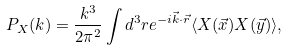<formula> <loc_0><loc_0><loc_500><loc_500>P _ { X } ( k ) = \frac { k ^ { 3 } } { 2 \pi ^ { 2 } } \int d ^ { 3 } r e ^ { - i \vec { k } \cdot \vec { r } } \langle X ( \vec { x } ) X ( \vec { y } ) \rangle ,</formula> 